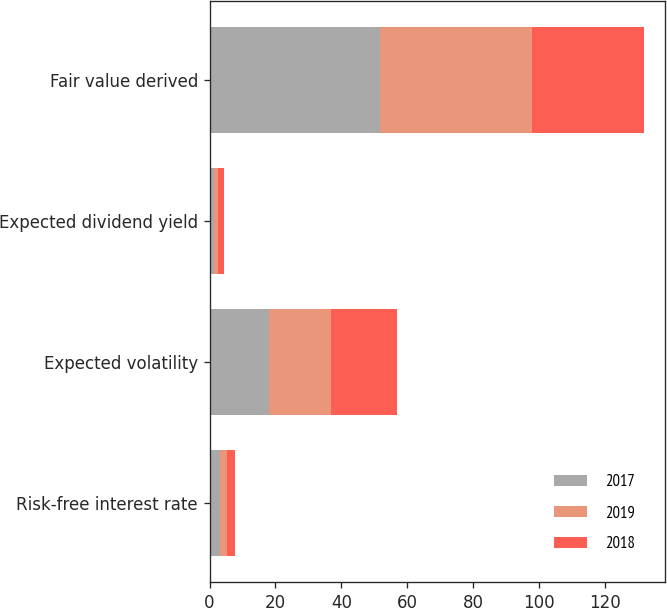<chart> <loc_0><loc_0><loc_500><loc_500><stacked_bar_chart><ecel><fcel>Risk-free interest rate<fcel>Expected volatility<fcel>Expected dividend yield<fcel>Fair value derived<nl><fcel>2017<fcel>3.05<fcel>18<fcel>1.27<fcel>51.86<nl><fcel>2019<fcel>2.32<fcel>19<fcel>1.33<fcel>46.1<nl><fcel>2018<fcel>2.33<fcel>20<fcel>1.71<fcel>33.81<nl></chart> 